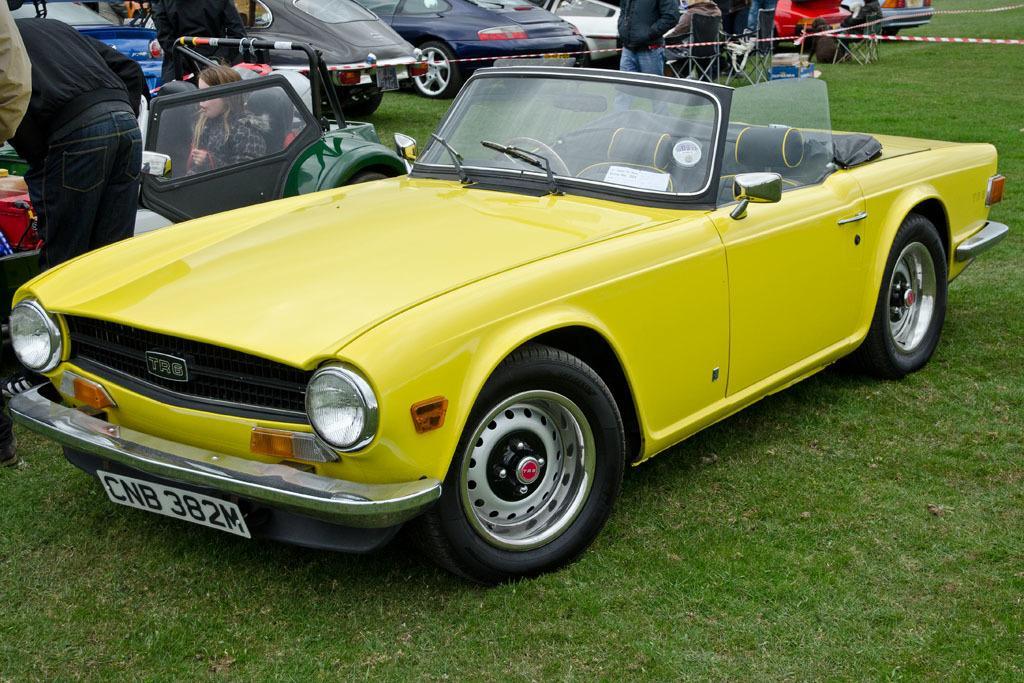Could you give a brief overview of what you see in this image? This picture is taken from the outside of the city. In this image, in the middle, we can see a car which is placed on the grass. On the left side, we can see a person. On the left side, we can also see hand of a person. On the left side, we can see a woman sitting in the vehicle. On the left side, we can also see some objects. In the background, we can see a group of people, vehicles which are placed on the grass and a cloth. At the bottom, we can see a grass. 